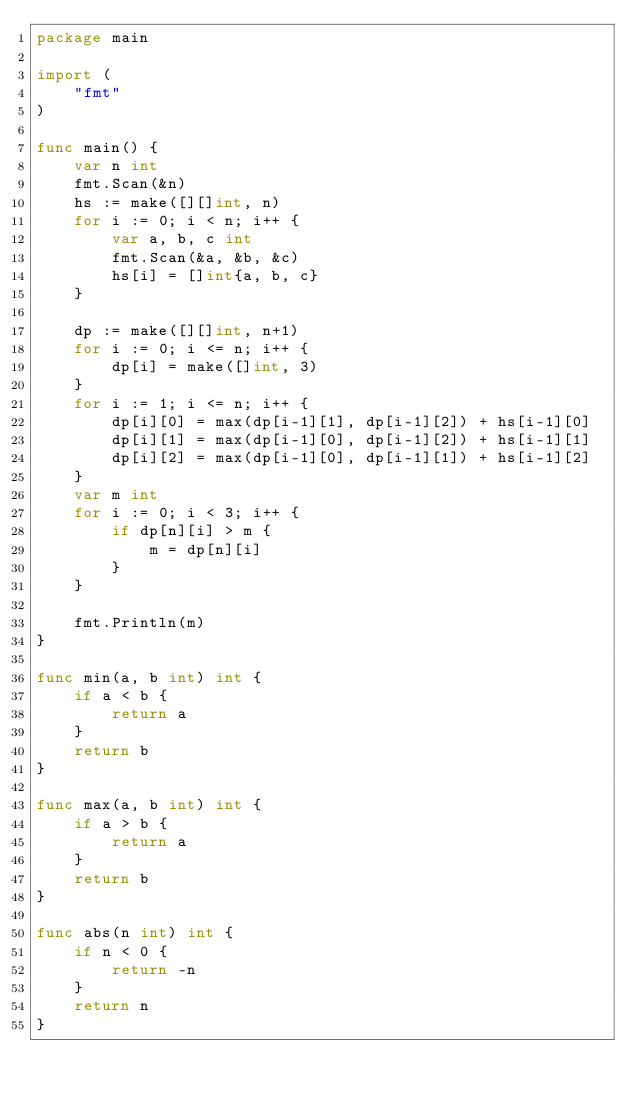Convert code to text. <code><loc_0><loc_0><loc_500><loc_500><_Go_>package main

import (
    "fmt"
)

func main() {
    var n int
    fmt.Scan(&n)
    hs := make([][]int, n)
    for i := 0; i < n; i++ {
        var a, b, c int
        fmt.Scan(&a, &b, &c)
        hs[i] = []int{a, b, c}
    }

    dp := make([][]int, n+1)
    for i := 0; i <= n; i++ {
        dp[i] = make([]int, 3)
    }
    for i := 1; i <= n; i++ {
        dp[i][0] = max(dp[i-1][1], dp[i-1][2]) + hs[i-1][0]
        dp[i][1] = max(dp[i-1][0], dp[i-1][2]) + hs[i-1][1]
        dp[i][2] = max(dp[i-1][0], dp[i-1][1]) + hs[i-1][2]
    }
    var m int
    for i := 0; i < 3; i++ {
        if dp[n][i] > m {
            m = dp[n][i]
        }
    }

    fmt.Println(m)
}

func min(a, b int) int {
    if a < b {
        return a
    }
    return b
}

func max(a, b int) int {
    if a > b {
        return a
    }
    return b
}

func abs(n int) int {
    if n < 0 {
        return -n
    }
    return n
}
</code> 